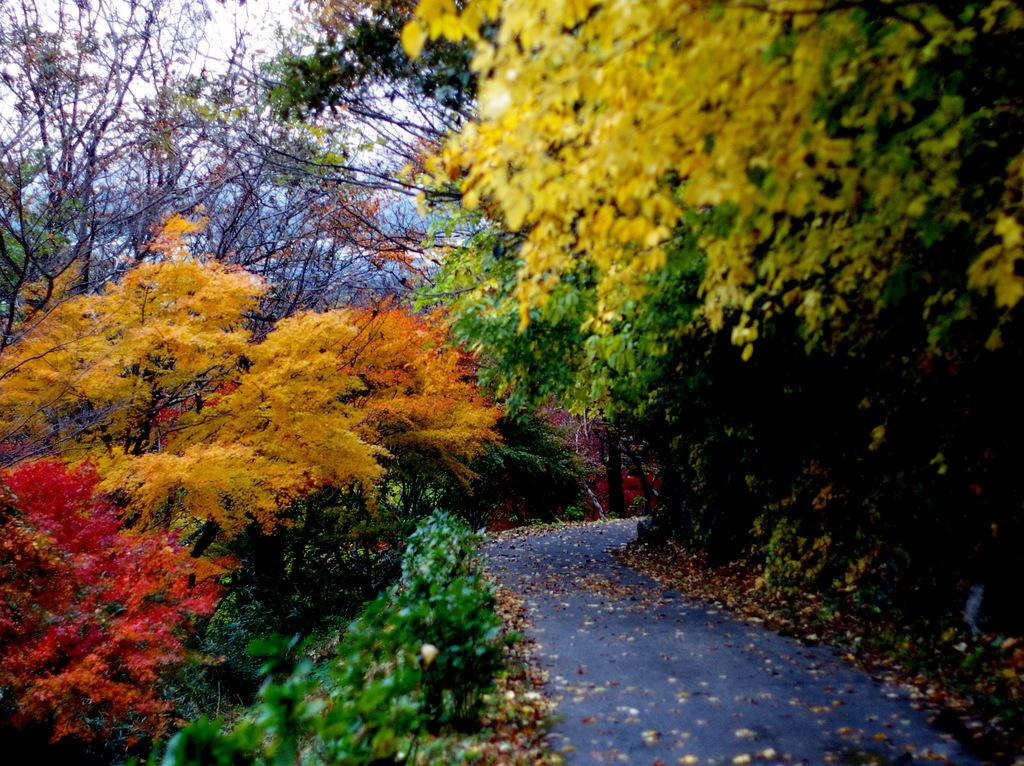What is in the foreground of the image? There is a road in the foreground of the image. What can be seen on either side of the road? There are trees with colorful leaves on either side of the road. What is visible in the background of the image? The sky is visible in the background of the image. How many cows are grazing in the background of the image? There are no cows present in the image; it features a road with trees on either side and a visible sky in the background. 